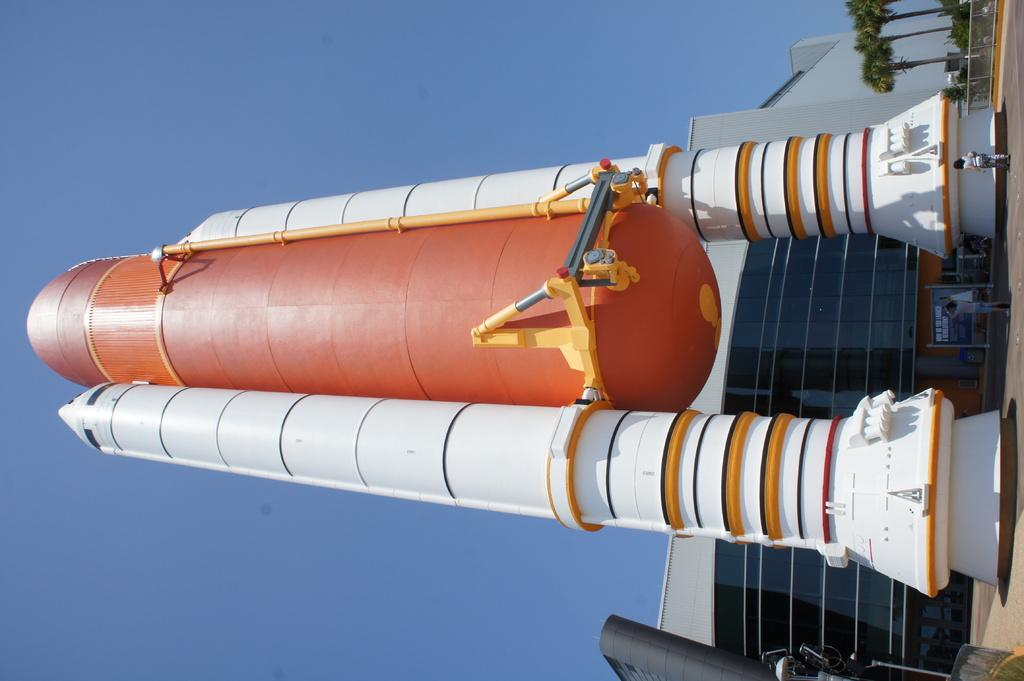What is the main object in the image? There is an object in the shape of a rocket in the image. What can be seen in the background of the image? There is a building, a board, trees, two persons, and the sky visible in the background of the image. What type of suggestion is being made by the baseball in the image? There is no baseball present in the image, so it cannot be making any suggestions. 